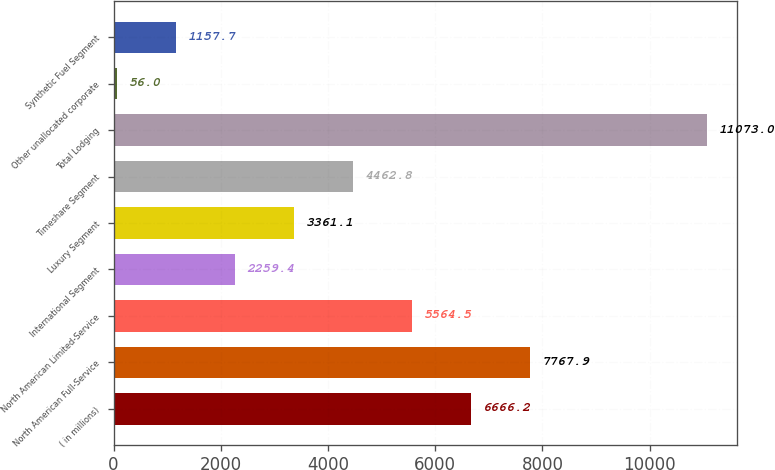Convert chart to OTSL. <chart><loc_0><loc_0><loc_500><loc_500><bar_chart><fcel>( in millions)<fcel>North American Full-Service<fcel>North American Limited-Service<fcel>International Segment<fcel>Luxury Segment<fcel>Timeshare Segment<fcel>Total Lodging<fcel>Other unallocated corporate<fcel>Synthetic Fuel Segment<nl><fcel>6666.2<fcel>7767.9<fcel>5564.5<fcel>2259.4<fcel>3361.1<fcel>4462.8<fcel>11073<fcel>56<fcel>1157.7<nl></chart> 